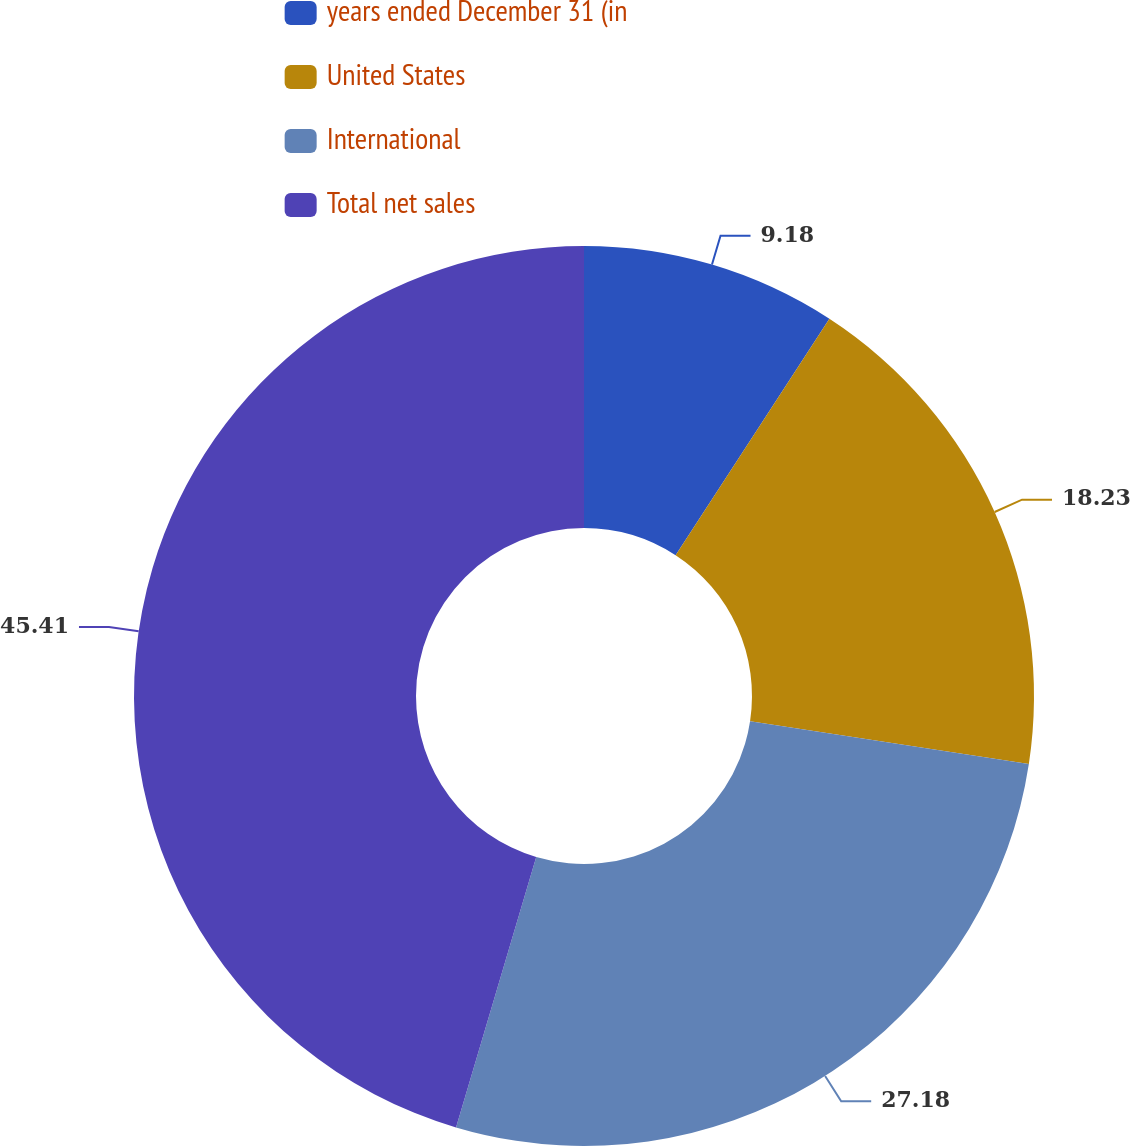Convert chart. <chart><loc_0><loc_0><loc_500><loc_500><pie_chart><fcel>years ended December 31 (in<fcel>United States<fcel>International<fcel>Total net sales<nl><fcel>9.18%<fcel>18.23%<fcel>27.18%<fcel>45.41%<nl></chart> 